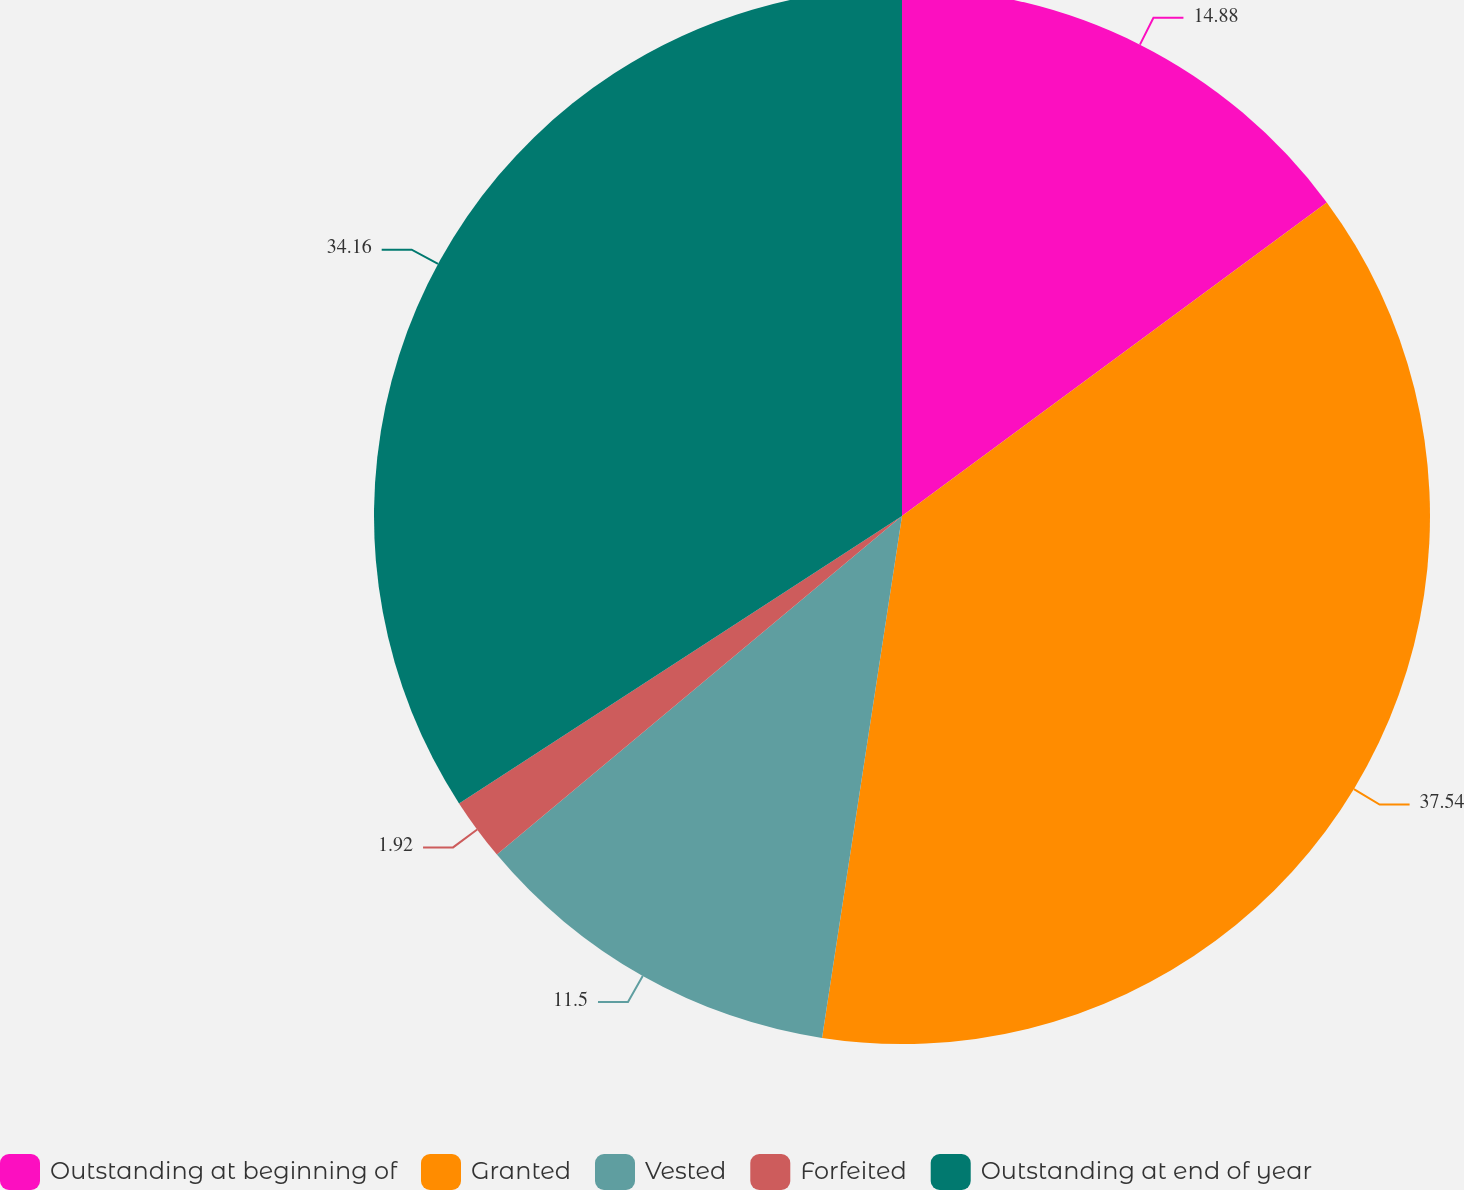Convert chart. <chart><loc_0><loc_0><loc_500><loc_500><pie_chart><fcel>Outstanding at beginning of<fcel>Granted<fcel>Vested<fcel>Forfeited<fcel>Outstanding at end of year<nl><fcel>14.88%<fcel>37.54%<fcel>11.5%<fcel>1.92%<fcel>34.16%<nl></chart> 